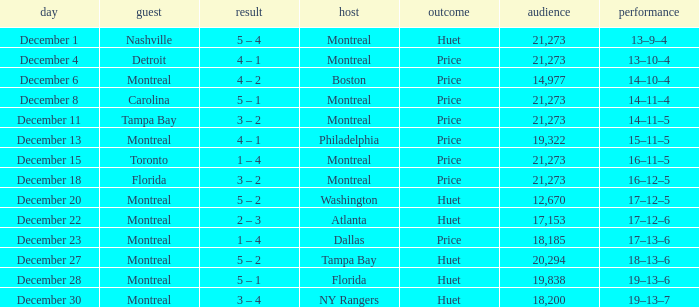What is the decision when the record is 13–10–4? Price. 